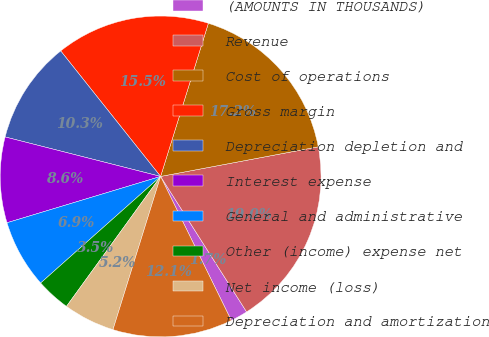Convert chart to OTSL. <chart><loc_0><loc_0><loc_500><loc_500><pie_chart><fcel>(AMOUNTS IN THOUSANDS)<fcel>Revenue<fcel>Cost of operations<fcel>Gross margin<fcel>Depreciation depletion and<fcel>Interest expense<fcel>General and administrative<fcel>Other (income) expense net<fcel>Net income (loss)<fcel>Depreciation and amortization<nl><fcel>1.74%<fcel>18.95%<fcel>17.23%<fcel>15.51%<fcel>10.34%<fcel>8.62%<fcel>6.9%<fcel>3.46%<fcel>5.18%<fcel>12.06%<nl></chart> 